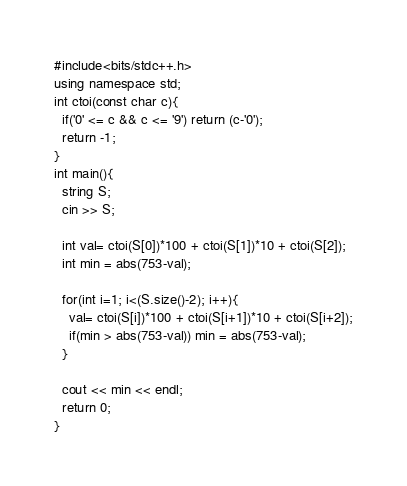Convert code to text. <code><loc_0><loc_0><loc_500><loc_500><_C++_>#include<bits/stdc++.h>
using namespace std;
int ctoi(const char c){
  if('0' <= c && c <= '9') return (c-'0');
  return -1;
}
int main(){
  string S;
  cin >> S;
  
  int val= ctoi(S[0])*100 + ctoi(S[1])*10 + ctoi(S[2]);
  int min = abs(753-val);
  
  for(int i=1; i<(S.size()-2); i++){
    val= ctoi(S[i])*100 + ctoi(S[i+1])*10 + ctoi(S[i+2]);
    if(min > abs(753-val)) min = abs(753-val);
  }

  cout << min << endl;
  return 0;
}</code> 